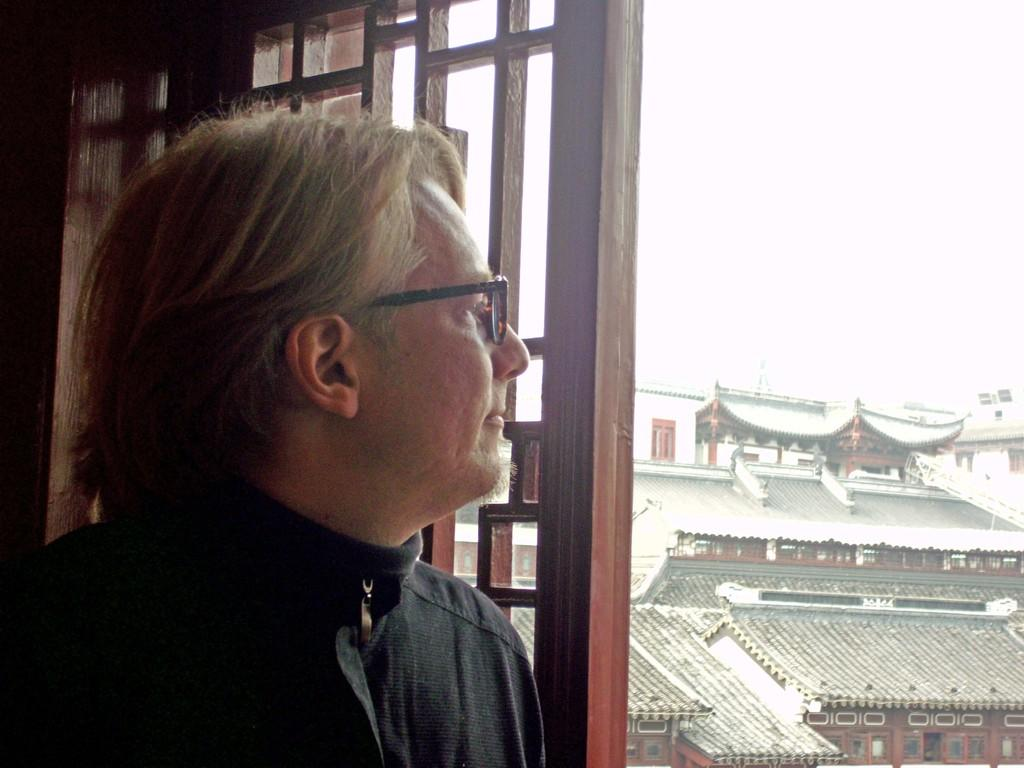What is the main subject of the image? There is a person standing in the image. What is the person wearing? The person is wearing a black dress. What can be seen in the background of the image? There are buildings in the background of the image. What colors are the buildings? The buildings are in white and brown colors. What is visible in the sky in the background of the image? The sky is visible in the background of the image, and it is white in color. What type of hydrant is visible in the image? There is no hydrant present in the image. What observation is the person making in the image? The image does not provide any information about the person's observations or actions. 